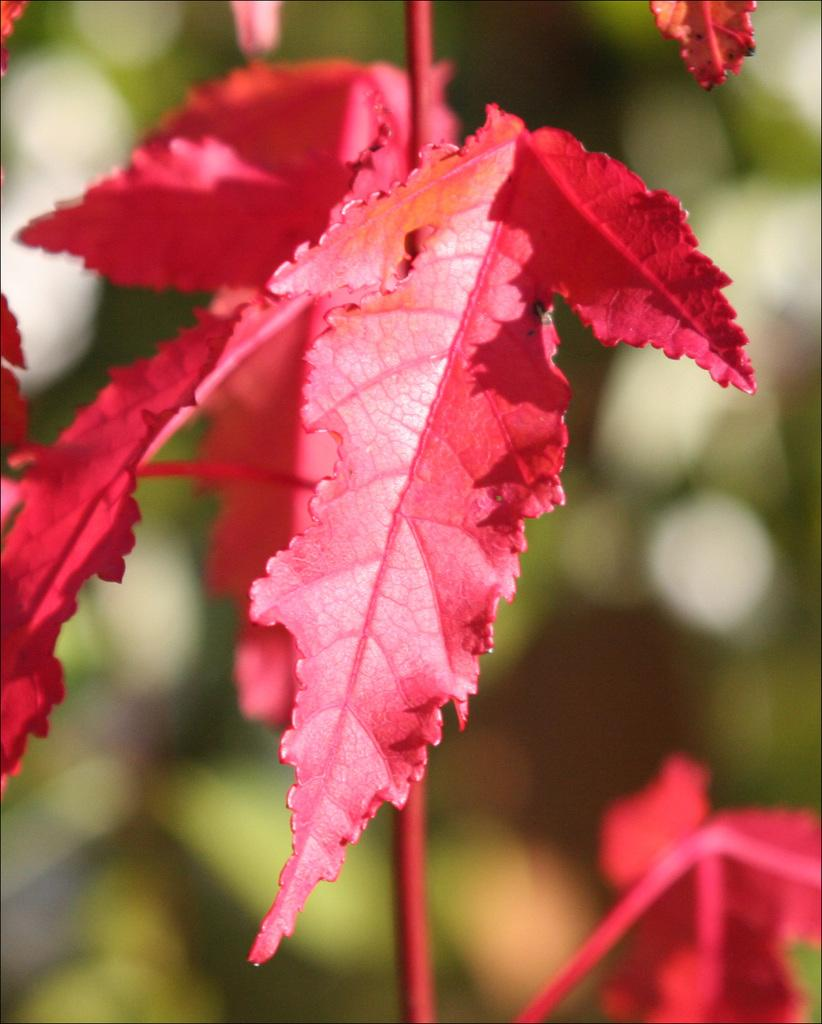What color are the leaves in the image? The leaves in the image are red. Can you describe the overall clarity of the image? The image is blurry. Based on the provided facts, can you confirm the presence of trees in the background of the image? The presence of trees in the background of the image is not explicitly confirmed in the transcript. How many cows are visible in the image? There are no cows present in the image. What offer is being made by the trees in the background of the image? There is no offer being made by the trees in the background of the image, as the presence of trees is not explicitly confirmed. 